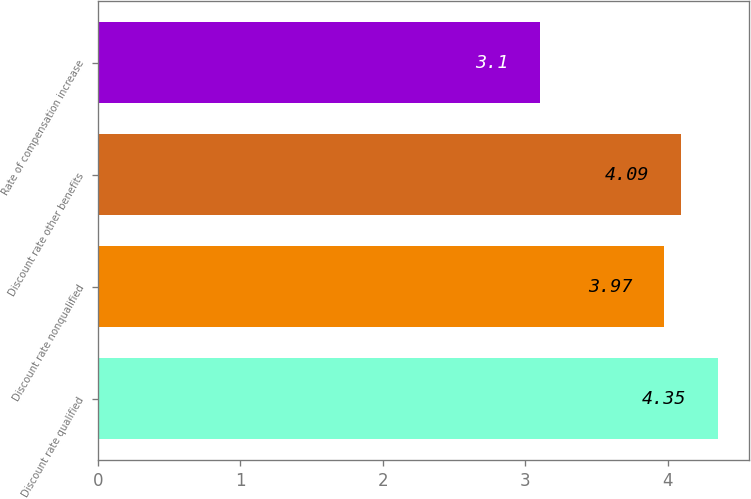Convert chart. <chart><loc_0><loc_0><loc_500><loc_500><bar_chart><fcel>Discount rate qualified<fcel>Discount rate nonqualified<fcel>Discount rate other benefits<fcel>Rate of compensation increase<nl><fcel>4.35<fcel>3.97<fcel>4.09<fcel>3.1<nl></chart> 